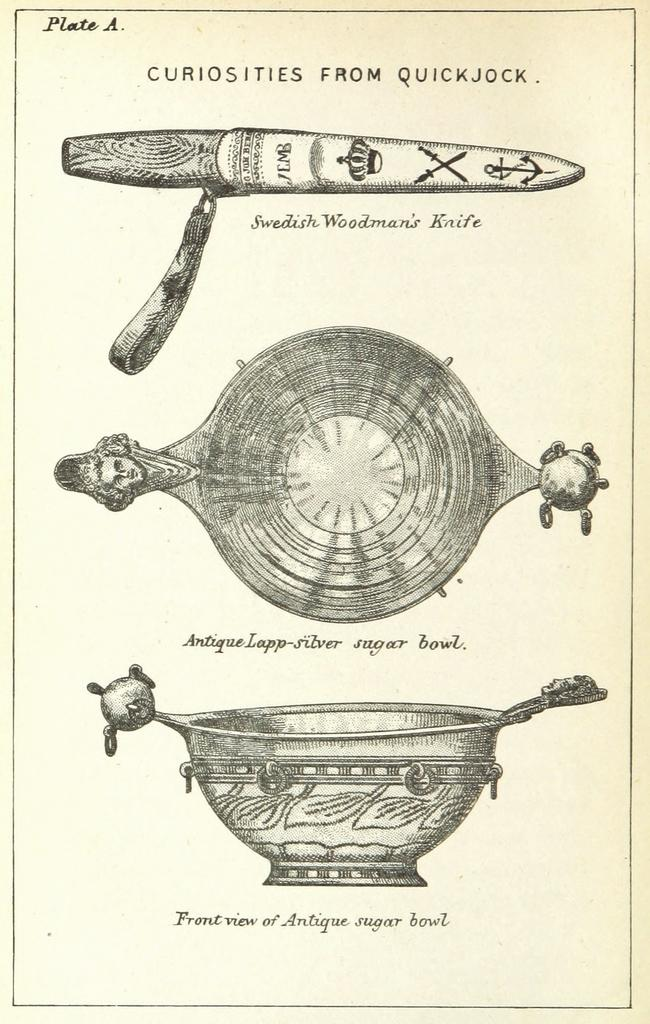What object is depicted in the image that is typically used for cutting? There is a depiction of a knife in the image. How many bowls are visible in the image? There are two bowls in the image. What is written or printed on the bowls? The bowls have text on them. What type of pest can be seen crawling on the knife in the image? There are no pests visible in the image, and the knife is not depicted as having any pests on it. 